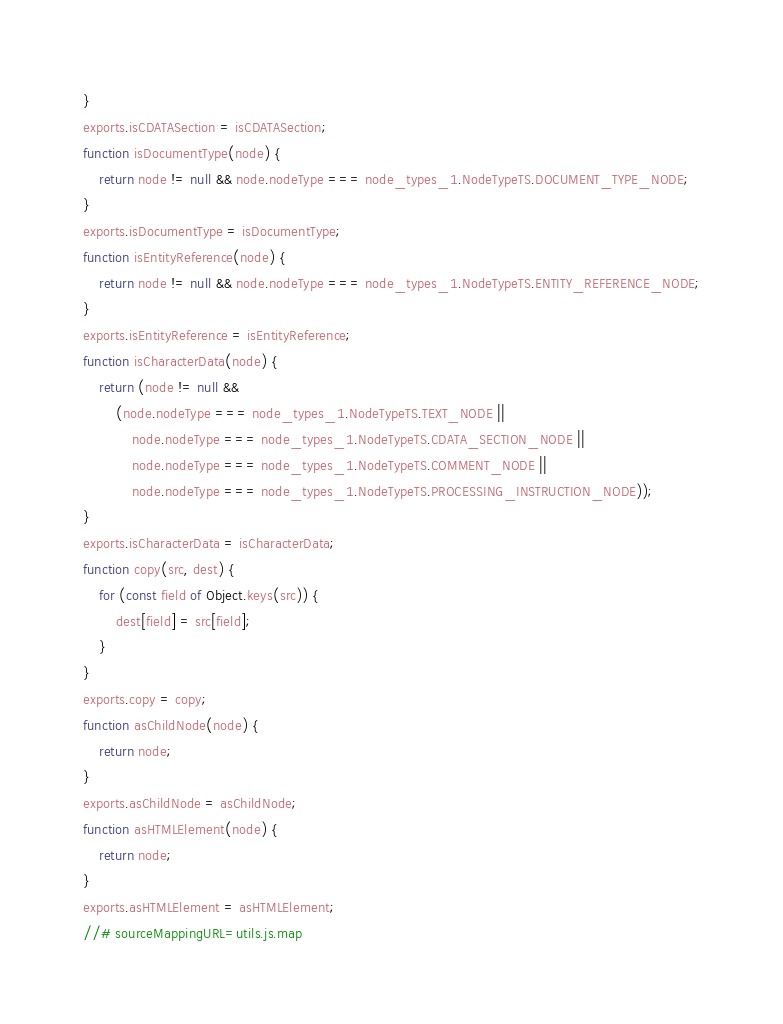<code> <loc_0><loc_0><loc_500><loc_500><_JavaScript_>}
exports.isCDATASection = isCDATASection;
function isDocumentType(node) {
    return node != null && node.nodeType === node_types_1.NodeTypeTS.DOCUMENT_TYPE_NODE;
}
exports.isDocumentType = isDocumentType;
function isEntityReference(node) {
    return node != null && node.nodeType === node_types_1.NodeTypeTS.ENTITY_REFERENCE_NODE;
}
exports.isEntityReference = isEntityReference;
function isCharacterData(node) {
    return (node != null &&
        (node.nodeType === node_types_1.NodeTypeTS.TEXT_NODE ||
            node.nodeType === node_types_1.NodeTypeTS.CDATA_SECTION_NODE ||
            node.nodeType === node_types_1.NodeTypeTS.COMMENT_NODE ||
            node.nodeType === node_types_1.NodeTypeTS.PROCESSING_INSTRUCTION_NODE));
}
exports.isCharacterData = isCharacterData;
function copy(src, dest) {
    for (const field of Object.keys(src)) {
        dest[field] = src[field];
    }
}
exports.copy = copy;
function asChildNode(node) {
    return node;
}
exports.asChildNode = asChildNode;
function asHTMLElement(node) {
    return node;
}
exports.asHTMLElement = asHTMLElement;
//# sourceMappingURL=utils.js.map</code> 